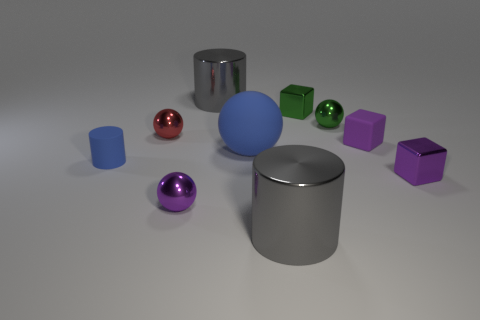Subtract 2 balls. How many balls are left? 2 Subtract all green spheres. How many spheres are left? 3 Subtract all blue balls. How many balls are left? 3 Subtract all gray spheres. Subtract all yellow cylinders. How many spheres are left? 4 Add 7 metal balls. How many metal balls are left? 10 Add 6 big yellow rubber cubes. How many big yellow rubber cubes exist? 6 Subtract 0 cyan spheres. How many objects are left? 10 Subtract all blocks. How many objects are left? 7 Subtract all tiny blue cylinders. Subtract all big brown shiny spheres. How many objects are left? 9 